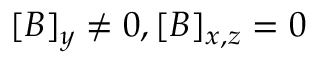<formula> <loc_0><loc_0><loc_500><loc_500>[ B ] _ { y } \neq 0 , [ B ] _ { x , z } = 0</formula> 